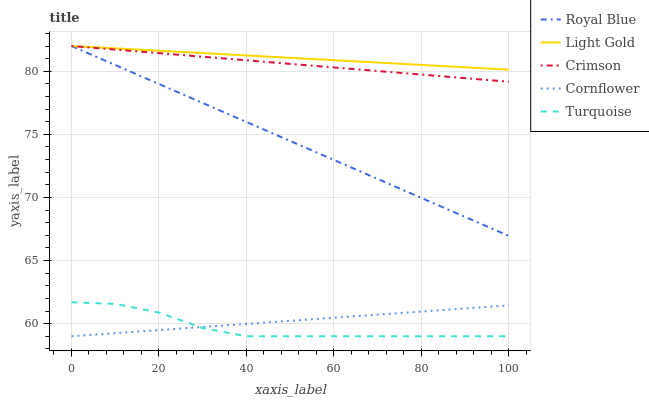Does Turquoise have the minimum area under the curve?
Answer yes or no. Yes. Does Light Gold have the maximum area under the curve?
Answer yes or no. Yes. Does Royal Blue have the minimum area under the curve?
Answer yes or no. No. Does Royal Blue have the maximum area under the curve?
Answer yes or no. No. Is Cornflower the smoothest?
Answer yes or no. Yes. Is Turquoise the roughest?
Answer yes or no. Yes. Is Royal Blue the smoothest?
Answer yes or no. No. Is Royal Blue the roughest?
Answer yes or no. No. Does Turquoise have the lowest value?
Answer yes or no. Yes. Does Royal Blue have the lowest value?
Answer yes or no. No. Does Light Gold have the highest value?
Answer yes or no. Yes. Does Turquoise have the highest value?
Answer yes or no. No. Is Turquoise less than Royal Blue?
Answer yes or no. Yes. Is Light Gold greater than Cornflower?
Answer yes or no. Yes. Does Turquoise intersect Cornflower?
Answer yes or no. Yes. Is Turquoise less than Cornflower?
Answer yes or no. No. Is Turquoise greater than Cornflower?
Answer yes or no. No. Does Turquoise intersect Royal Blue?
Answer yes or no. No. 